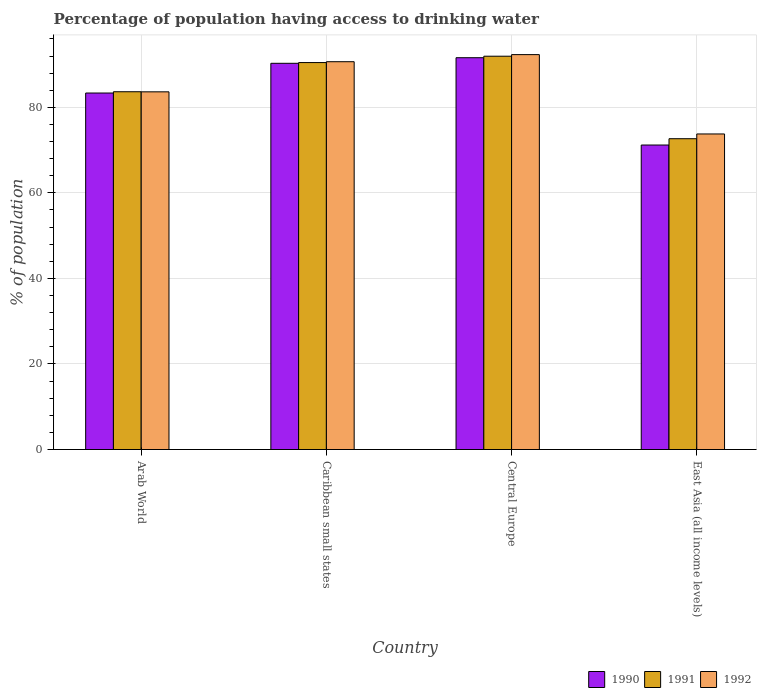How many groups of bars are there?
Give a very brief answer. 4. Are the number of bars per tick equal to the number of legend labels?
Provide a short and direct response. Yes. How many bars are there on the 2nd tick from the left?
Ensure brevity in your answer.  3. What is the label of the 1st group of bars from the left?
Your response must be concise. Arab World. In how many cases, is the number of bars for a given country not equal to the number of legend labels?
Offer a very short reply. 0. What is the percentage of population having access to drinking water in 1992 in Central Europe?
Provide a succinct answer. 92.32. Across all countries, what is the maximum percentage of population having access to drinking water in 1992?
Offer a terse response. 92.32. Across all countries, what is the minimum percentage of population having access to drinking water in 1991?
Ensure brevity in your answer.  72.66. In which country was the percentage of population having access to drinking water in 1990 maximum?
Provide a short and direct response. Central Europe. In which country was the percentage of population having access to drinking water in 1991 minimum?
Provide a succinct answer. East Asia (all income levels). What is the total percentage of population having access to drinking water in 1990 in the graph?
Keep it short and to the point. 336.43. What is the difference between the percentage of population having access to drinking water in 1990 in Arab World and that in East Asia (all income levels)?
Ensure brevity in your answer.  12.16. What is the difference between the percentage of population having access to drinking water in 1991 in East Asia (all income levels) and the percentage of population having access to drinking water in 1990 in Caribbean small states?
Keep it short and to the point. -17.63. What is the average percentage of population having access to drinking water in 1990 per country?
Make the answer very short. 84.11. What is the difference between the percentage of population having access to drinking water of/in 1991 and percentage of population having access to drinking water of/in 1992 in East Asia (all income levels)?
Make the answer very short. -1.11. In how many countries, is the percentage of population having access to drinking water in 1990 greater than 24 %?
Ensure brevity in your answer.  4. What is the ratio of the percentage of population having access to drinking water in 1991 in Caribbean small states to that in Central Europe?
Your response must be concise. 0.98. Is the difference between the percentage of population having access to drinking water in 1991 in Arab World and East Asia (all income levels) greater than the difference between the percentage of population having access to drinking water in 1992 in Arab World and East Asia (all income levels)?
Offer a very short reply. Yes. What is the difference between the highest and the second highest percentage of population having access to drinking water in 1992?
Provide a short and direct response. 7.04. What is the difference between the highest and the lowest percentage of population having access to drinking water in 1991?
Ensure brevity in your answer.  19.29. Is the sum of the percentage of population having access to drinking water in 1991 in Caribbean small states and Central Europe greater than the maximum percentage of population having access to drinking water in 1990 across all countries?
Make the answer very short. Yes. What does the 1st bar from the left in Central Europe represents?
Offer a very short reply. 1990. What does the 1st bar from the right in Arab World represents?
Your answer should be very brief. 1992. Is it the case that in every country, the sum of the percentage of population having access to drinking water in 1991 and percentage of population having access to drinking water in 1992 is greater than the percentage of population having access to drinking water in 1990?
Make the answer very short. Yes. How many bars are there?
Your answer should be compact. 12. How many countries are there in the graph?
Your answer should be compact. 4. What is the difference between two consecutive major ticks on the Y-axis?
Offer a very short reply. 20. Does the graph contain any zero values?
Provide a succinct answer. No. How many legend labels are there?
Your answer should be very brief. 3. How are the legend labels stacked?
Your answer should be compact. Horizontal. What is the title of the graph?
Your response must be concise. Percentage of population having access to drinking water. Does "1973" appear as one of the legend labels in the graph?
Provide a short and direct response. No. What is the label or title of the Y-axis?
Your answer should be very brief. % of population. What is the % of population of 1990 in Arab World?
Offer a terse response. 83.35. What is the % of population of 1991 in Arab World?
Give a very brief answer. 83.64. What is the % of population in 1992 in Arab World?
Make the answer very short. 83.62. What is the % of population in 1990 in Caribbean small states?
Your response must be concise. 90.29. What is the % of population in 1991 in Caribbean small states?
Your answer should be compact. 90.47. What is the % of population in 1992 in Caribbean small states?
Provide a short and direct response. 90.67. What is the % of population in 1990 in Central Europe?
Keep it short and to the point. 91.6. What is the % of population of 1991 in Central Europe?
Give a very brief answer. 91.95. What is the % of population of 1992 in Central Europe?
Provide a short and direct response. 92.32. What is the % of population in 1990 in East Asia (all income levels)?
Keep it short and to the point. 71.19. What is the % of population of 1991 in East Asia (all income levels)?
Make the answer very short. 72.66. What is the % of population in 1992 in East Asia (all income levels)?
Make the answer very short. 73.78. Across all countries, what is the maximum % of population in 1990?
Offer a very short reply. 91.6. Across all countries, what is the maximum % of population of 1991?
Provide a succinct answer. 91.95. Across all countries, what is the maximum % of population in 1992?
Offer a terse response. 92.32. Across all countries, what is the minimum % of population in 1990?
Keep it short and to the point. 71.19. Across all countries, what is the minimum % of population of 1991?
Give a very brief answer. 72.66. Across all countries, what is the minimum % of population of 1992?
Offer a very short reply. 73.78. What is the total % of population in 1990 in the graph?
Provide a short and direct response. 336.43. What is the total % of population of 1991 in the graph?
Provide a succinct answer. 338.72. What is the total % of population in 1992 in the graph?
Offer a terse response. 340.39. What is the difference between the % of population in 1990 in Arab World and that in Caribbean small states?
Make the answer very short. -6.95. What is the difference between the % of population in 1991 in Arab World and that in Caribbean small states?
Ensure brevity in your answer.  -6.82. What is the difference between the % of population of 1992 in Arab World and that in Caribbean small states?
Make the answer very short. -7.04. What is the difference between the % of population of 1990 in Arab World and that in Central Europe?
Keep it short and to the point. -8.26. What is the difference between the % of population of 1991 in Arab World and that in Central Europe?
Your response must be concise. -8.31. What is the difference between the % of population in 1992 in Arab World and that in Central Europe?
Offer a very short reply. -8.7. What is the difference between the % of population in 1990 in Arab World and that in East Asia (all income levels)?
Offer a terse response. 12.16. What is the difference between the % of population in 1991 in Arab World and that in East Asia (all income levels)?
Offer a very short reply. 10.98. What is the difference between the % of population in 1992 in Arab World and that in East Asia (all income levels)?
Make the answer very short. 9.85. What is the difference between the % of population of 1990 in Caribbean small states and that in Central Europe?
Your response must be concise. -1.31. What is the difference between the % of population of 1991 in Caribbean small states and that in Central Europe?
Provide a succinct answer. -1.49. What is the difference between the % of population in 1992 in Caribbean small states and that in Central Europe?
Keep it short and to the point. -1.66. What is the difference between the % of population of 1990 in Caribbean small states and that in East Asia (all income levels)?
Provide a succinct answer. 19.11. What is the difference between the % of population in 1991 in Caribbean small states and that in East Asia (all income levels)?
Make the answer very short. 17.8. What is the difference between the % of population of 1992 in Caribbean small states and that in East Asia (all income levels)?
Offer a very short reply. 16.89. What is the difference between the % of population in 1990 in Central Europe and that in East Asia (all income levels)?
Your response must be concise. 20.41. What is the difference between the % of population of 1991 in Central Europe and that in East Asia (all income levels)?
Your answer should be compact. 19.29. What is the difference between the % of population in 1992 in Central Europe and that in East Asia (all income levels)?
Provide a short and direct response. 18.55. What is the difference between the % of population of 1990 in Arab World and the % of population of 1991 in Caribbean small states?
Keep it short and to the point. -7.12. What is the difference between the % of population in 1990 in Arab World and the % of population in 1992 in Caribbean small states?
Keep it short and to the point. -7.32. What is the difference between the % of population in 1991 in Arab World and the % of population in 1992 in Caribbean small states?
Offer a very short reply. -7.02. What is the difference between the % of population in 1990 in Arab World and the % of population in 1991 in Central Europe?
Make the answer very short. -8.61. What is the difference between the % of population of 1990 in Arab World and the % of population of 1992 in Central Europe?
Keep it short and to the point. -8.98. What is the difference between the % of population of 1991 in Arab World and the % of population of 1992 in Central Europe?
Your response must be concise. -8.68. What is the difference between the % of population in 1990 in Arab World and the % of population in 1991 in East Asia (all income levels)?
Provide a short and direct response. 10.68. What is the difference between the % of population in 1990 in Arab World and the % of population in 1992 in East Asia (all income levels)?
Your answer should be compact. 9.57. What is the difference between the % of population of 1991 in Arab World and the % of population of 1992 in East Asia (all income levels)?
Offer a terse response. 9.87. What is the difference between the % of population of 1990 in Caribbean small states and the % of population of 1991 in Central Europe?
Make the answer very short. -1.66. What is the difference between the % of population in 1990 in Caribbean small states and the % of population in 1992 in Central Europe?
Provide a short and direct response. -2.03. What is the difference between the % of population of 1991 in Caribbean small states and the % of population of 1992 in Central Europe?
Provide a succinct answer. -1.86. What is the difference between the % of population in 1990 in Caribbean small states and the % of population in 1991 in East Asia (all income levels)?
Your response must be concise. 17.63. What is the difference between the % of population in 1990 in Caribbean small states and the % of population in 1992 in East Asia (all income levels)?
Your response must be concise. 16.52. What is the difference between the % of population of 1991 in Caribbean small states and the % of population of 1992 in East Asia (all income levels)?
Make the answer very short. 16.69. What is the difference between the % of population in 1990 in Central Europe and the % of population in 1991 in East Asia (all income levels)?
Your answer should be very brief. 18.94. What is the difference between the % of population in 1990 in Central Europe and the % of population in 1992 in East Asia (all income levels)?
Provide a succinct answer. 17.83. What is the difference between the % of population of 1991 in Central Europe and the % of population of 1992 in East Asia (all income levels)?
Provide a succinct answer. 18.18. What is the average % of population of 1990 per country?
Provide a short and direct response. 84.11. What is the average % of population in 1991 per country?
Give a very brief answer. 84.68. What is the average % of population of 1992 per country?
Your response must be concise. 85.1. What is the difference between the % of population in 1990 and % of population in 1991 in Arab World?
Offer a very short reply. -0.3. What is the difference between the % of population in 1990 and % of population in 1992 in Arab World?
Provide a succinct answer. -0.28. What is the difference between the % of population in 1991 and % of population in 1992 in Arab World?
Give a very brief answer. 0.02. What is the difference between the % of population of 1990 and % of population of 1991 in Caribbean small states?
Your response must be concise. -0.17. What is the difference between the % of population of 1990 and % of population of 1992 in Caribbean small states?
Offer a very short reply. -0.37. What is the difference between the % of population in 1991 and % of population in 1992 in Caribbean small states?
Keep it short and to the point. -0.2. What is the difference between the % of population in 1990 and % of population in 1991 in Central Europe?
Provide a succinct answer. -0.35. What is the difference between the % of population of 1990 and % of population of 1992 in Central Europe?
Offer a terse response. -0.72. What is the difference between the % of population of 1991 and % of population of 1992 in Central Europe?
Offer a terse response. -0.37. What is the difference between the % of population of 1990 and % of population of 1991 in East Asia (all income levels)?
Offer a very short reply. -1.48. What is the difference between the % of population of 1990 and % of population of 1992 in East Asia (all income levels)?
Give a very brief answer. -2.59. What is the difference between the % of population in 1991 and % of population in 1992 in East Asia (all income levels)?
Ensure brevity in your answer.  -1.11. What is the ratio of the % of population of 1990 in Arab World to that in Caribbean small states?
Your response must be concise. 0.92. What is the ratio of the % of population of 1991 in Arab World to that in Caribbean small states?
Offer a terse response. 0.92. What is the ratio of the % of population in 1992 in Arab World to that in Caribbean small states?
Give a very brief answer. 0.92. What is the ratio of the % of population in 1990 in Arab World to that in Central Europe?
Provide a succinct answer. 0.91. What is the ratio of the % of population of 1991 in Arab World to that in Central Europe?
Provide a short and direct response. 0.91. What is the ratio of the % of population in 1992 in Arab World to that in Central Europe?
Give a very brief answer. 0.91. What is the ratio of the % of population of 1990 in Arab World to that in East Asia (all income levels)?
Make the answer very short. 1.17. What is the ratio of the % of population of 1991 in Arab World to that in East Asia (all income levels)?
Provide a short and direct response. 1.15. What is the ratio of the % of population of 1992 in Arab World to that in East Asia (all income levels)?
Offer a terse response. 1.13. What is the ratio of the % of population of 1990 in Caribbean small states to that in Central Europe?
Ensure brevity in your answer.  0.99. What is the ratio of the % of population of 1991 in Caribbean small states to that in Central Europe?
Give a very brief answer. 0.98. What is the ratio of the % of population of 1992 in Caribbean small states to that in Central Europe?
Keep it short and to the point. 0.98. What is the ratio of the % of population of 1990 in Caribbean small states to that in East Asia (all income levels)?
Offer a very short reply. 1.27. What is the ratio of the % of population in 1991 in Caribbean small states to that in East Asia (all income levels)?
Provide a succinct answer. 1.25. What is the ratio of the % of population in 1992 in Caribbean small states to that in East Asia (all income levels)?
Your answer should be compact. 1.23. What is the ratio of the % of population of 1990 in Central Europe to that in East Asia (all income levels)?
Your answer should be compact. 1.29. What is the ratio of the % of population in 1991 in Central Europe to that in East Asia (all income levels)?
Ensure brevity in your answer.  1.27. What is the ratio of the % of population of 1992 in Central Europe to that in East Asia (all income levels)?
Your answer should be very brief. 1.25. What is the difference between the highest and the second highest % of population of 1990?
Offer a very short reply. 1.31. What is the difference between the highest and the second highest % of population in 1991?
Make the answer very short. 1.49. What is the difference between the highest and the second highest % of population in 1992?
Your response must be concise. 1.66. What is the difference between the highest and the lowest % of population in 1990?
Your response must be concise. 20.41. What is the difference between the highest and the lowest % of population in 1991?
Offer a very short reply. 19.29. What is the difference between the highest and the lowest % of population in 1992?
Ensure brevity in your answer.  18.55. 